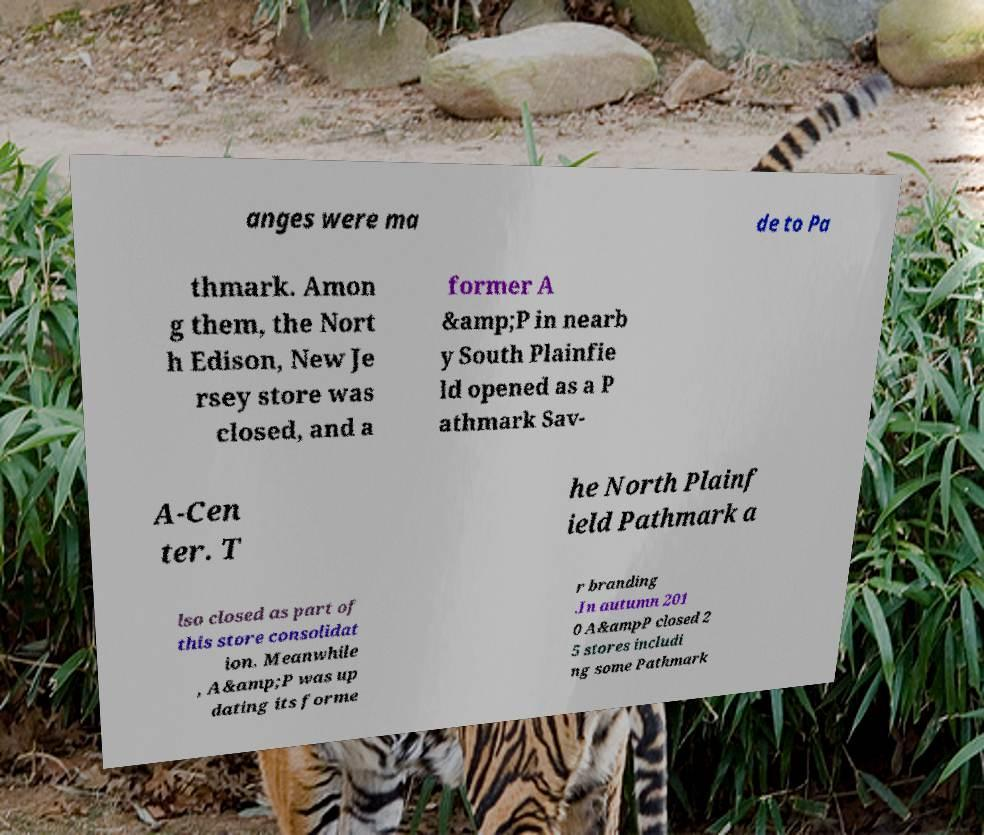Please read and relay the text visible in this image. What does it say? anges were ma de to Pa thmark. Amon g them, the Nort h Edison, New Je rsey store was closed, and a former A &amp;P in nearb y South Plainfie ld opened as a P athmark Sav- A-Cen ter. T he North Plainf ield Pathmark a lso closed as part of this store consolidat ion. Meanwhile , A&amp;P was up dating its forme r branding .In autumn 201 0 A&ampP closed 2 5 stores includi ng some Pathmark 